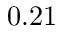Convert formula to latex. <formula><loc_0><loc_0><loc_500><loc_500>0 . 2 1</formula> 